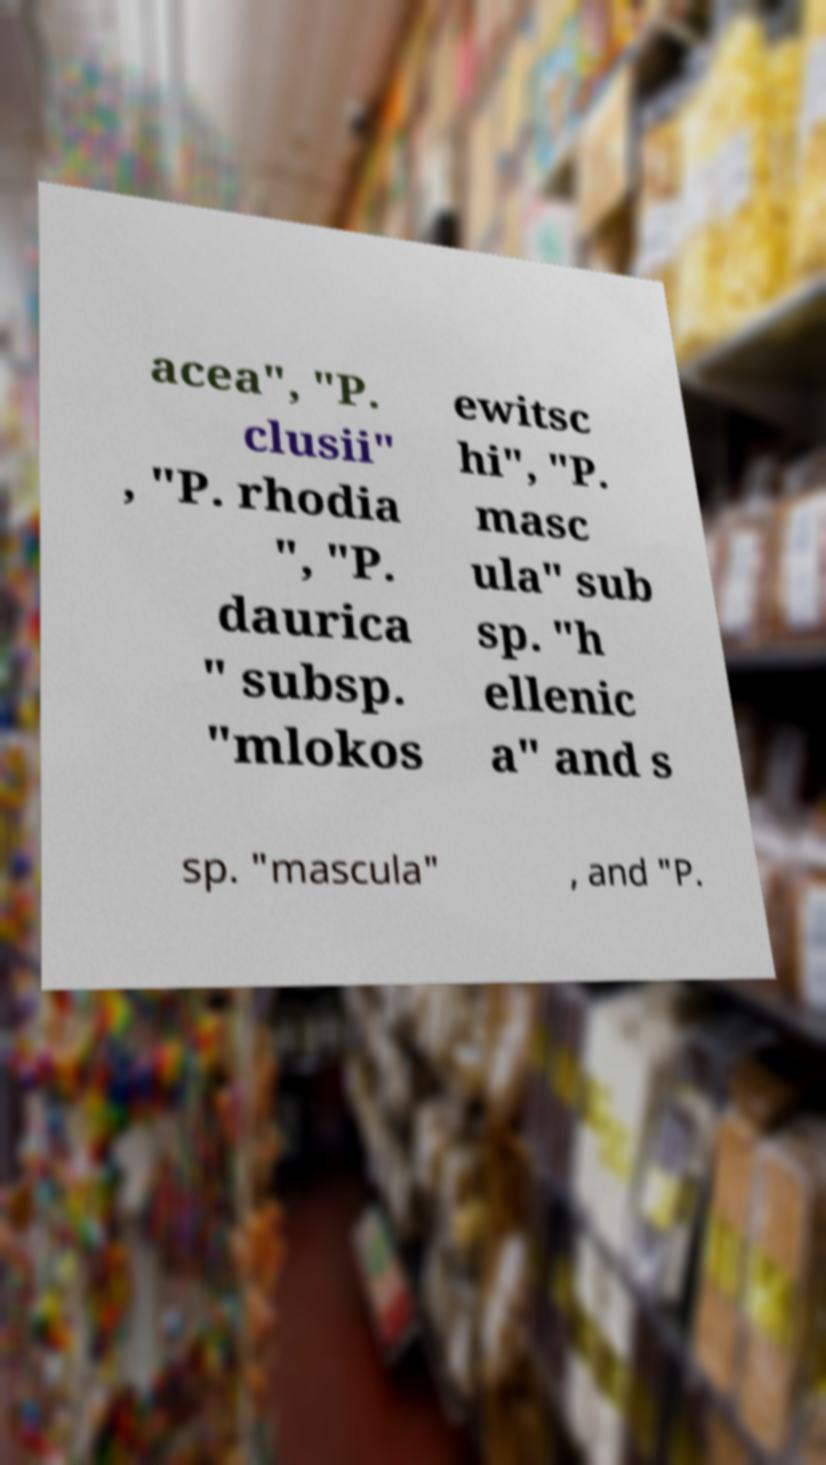I need the written content from this picture converted into text. Can you do that? acea", "P. clusii" , "P. rhodia ", "P. daurica " subsp. "mlokos ewitsc hi", "P. masc ula" sub sp. "h ellenic a" and s sp. "mascula" , and "P. 